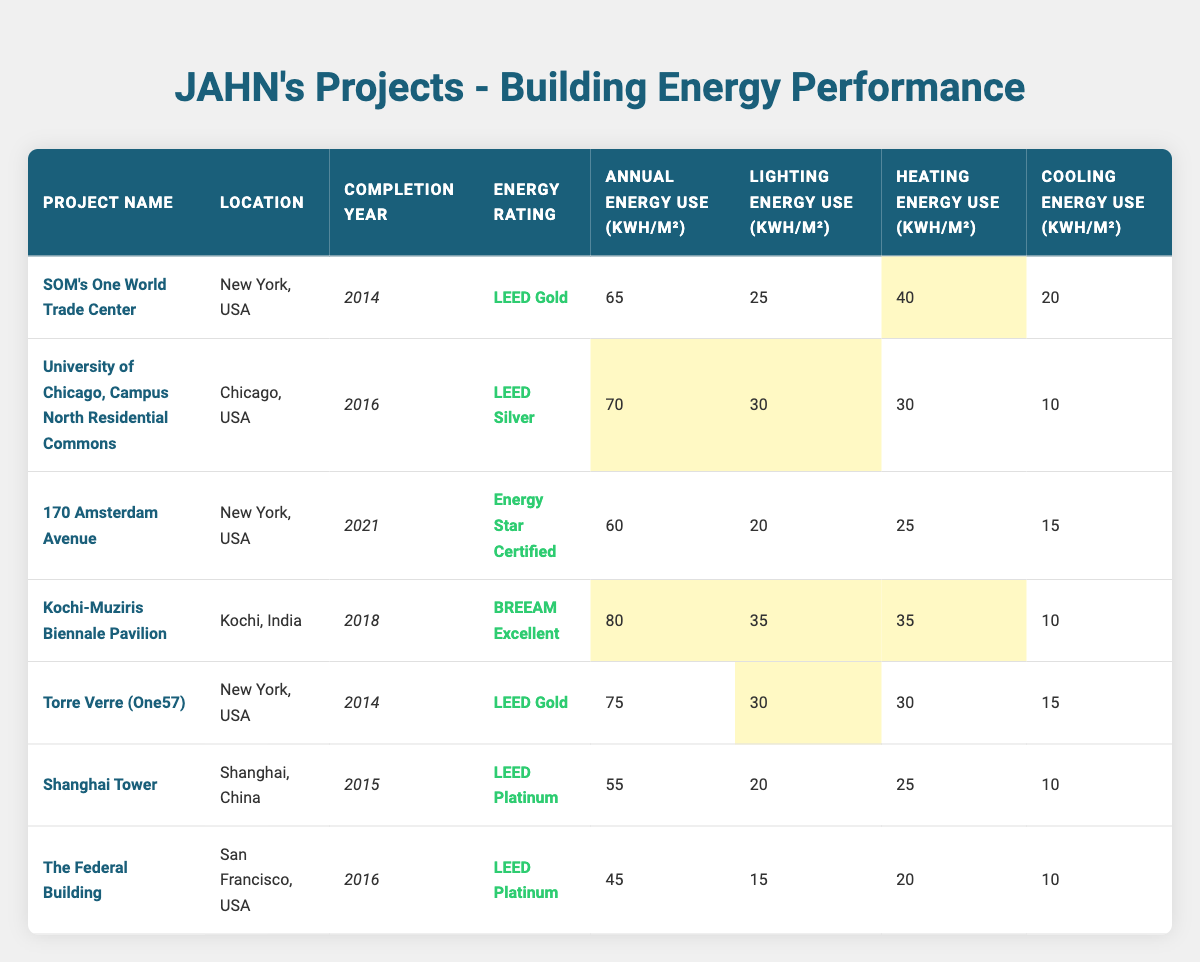What is the energy rating for the Shanghai Tower? The energy rating for the Shanghai Tower is listed in the table under the "Energy Rating" column, which shows "LEED Platinum."
Answer: LEED Platinum Which project has the highest annual energy use? To find the highest annual energy use, I look at the "Annual Energy Use" column and see that the Kochi-Muziris Biennale Pavilion has an annual energy use of 80 kWh/m², which is the largest value.
Answer: Kochi-Muziris Biennale Pavilion How many projects have a LEED Gold energy rating? In the table, there are two projects marked with "LEED Gold" in their energy rating: SOM's One World Trade Center and Torre Verre (One57).
Answer: 2 What is the average annual energy use across all projects? I sum the annual energy uses: 65 + 70 + 60 + 80 + 75 + 55 + 45 = 450 kWh/m². There are 7 projects, so the average is 450/7 ≈ 64.29.
Answer: 64.29 Is the lighting energy use for the University of Chicago project higher than the cooling energy use? Looking at the lighting energy use (30 kWh/m²) and the cooling energy use (10 kWh/m²) for the University of Chicago project, I see that 30 is greater than 10.
Answer: Yes Which project has the least amount of cooling energy use? I observe the "Cooling Energy Use" column and find that both the Kochi-Muziris Biennale Pavilion and the projects in Shanghai and San Francisco have 10 kWh/m², which are the minimum values.
Answer: 10 kWh/m² (Kochi-Muziris Biennale Pavilion, Shanghai Tower, The Federal Building) What is the difference in annual energy use between the highest and lowest projects? The highest annual energy use is 80 kWh/m² (Kochi-Muziris Biennale Pavilion) and the lowest is 45 kWh/m² (The Federal Building), so the difference is 80 - 45 = 35 kWh/m².
Answer: 35 Which project has the highest lighting energy use and what is the value? The project with the highest lighting energy use is the Kochi-Muziris Biennale Pavilion, which has a lighting energy use of 35 kWh/m², as seen in the "Lighting Energy Use" column.
Answer: Kochi-Muziris Biennale Pavilion, 35 kWh/m² Are there any projects located outside of the USA? I can check the "Location" column for projects outside of the USA and discover that the Kochi-Muziris Biennale Pavilion in Kochi, India is the only project not in the USA.
Answer: Yes What percentage of the projects are LEED certified (any level)? There are 4 LEED certified projects (LEED Platinum, LEED Gold, and LEED Silver) out of 7 total projects. Thus, the percentage is (4/7) * 100 ≈ 57.14%.
Answer: 57.14% 